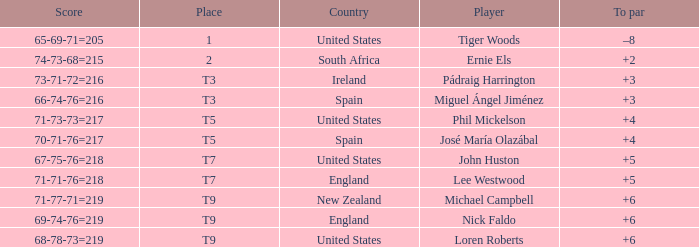What is Player, when Score is "66-74-76=216"? Miguel Ángel Jiménez. 